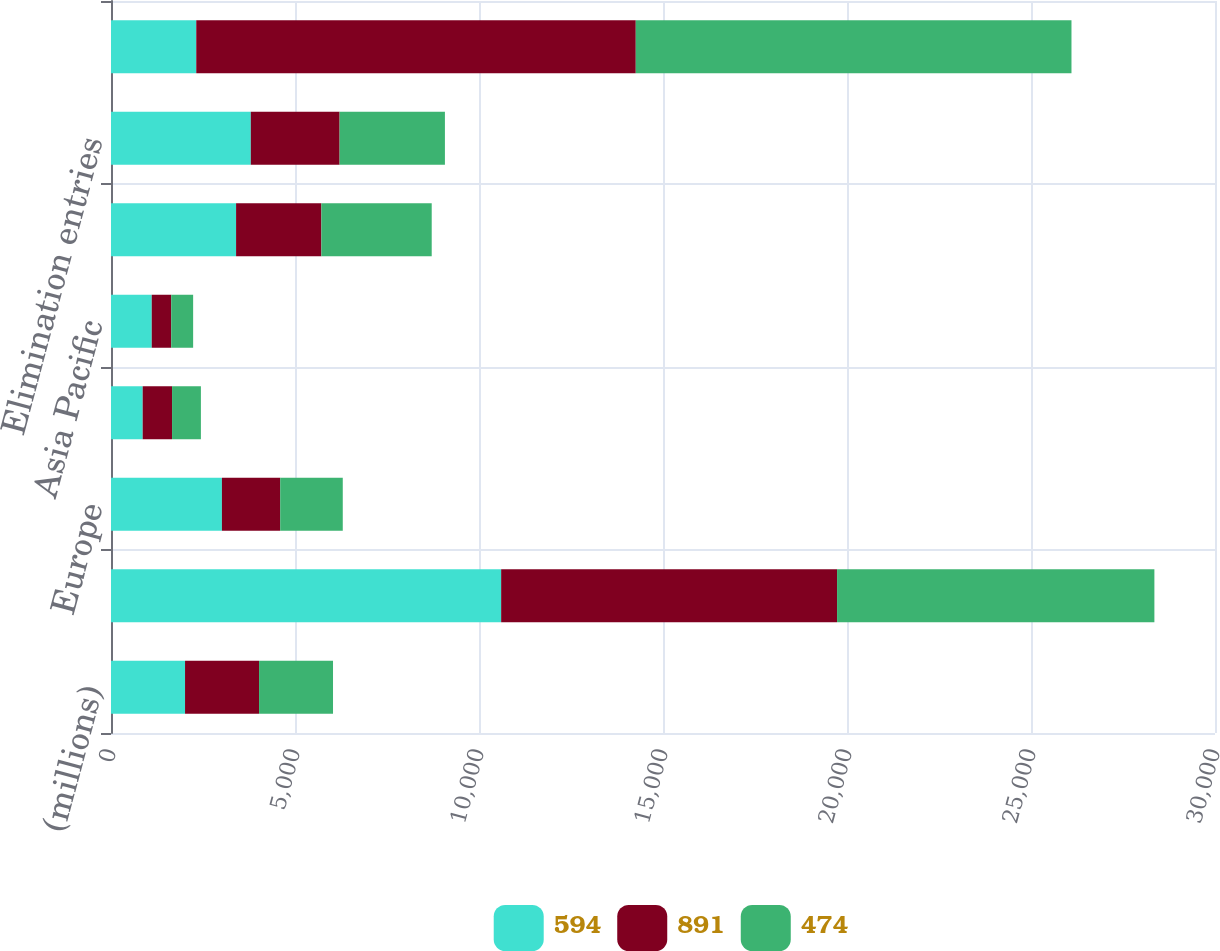Convert chart. <chart><loc_0><loc_0><loc_500><loc_500><stacked_bar_chart><ecel><fcel>(millions)<fcel>North America<fcel>Europe<fcel>Latin America<fcel>Asia Pacific<fcel>Corporate<fcel>Elimination entries<fcel>Consolidated<nl><fcel>594<fcel>2012<fcel>10602<fcel>3014<fcel>861<fcel>1107<fcel>3399<fcel>3799<fcel>2317<nl><fcel>891<fcel>2011<fcel>9128<fcel>1584<fcel>798<fcel>529<fcel>2317<fcel>2413<fcel>11943<nl><fcel>474<fcel>2010<fcel>8623<fcel>1700<fcel>784<fcel>596<fcel>2999<fcel>2862<fcel>11840<nl></chart> 